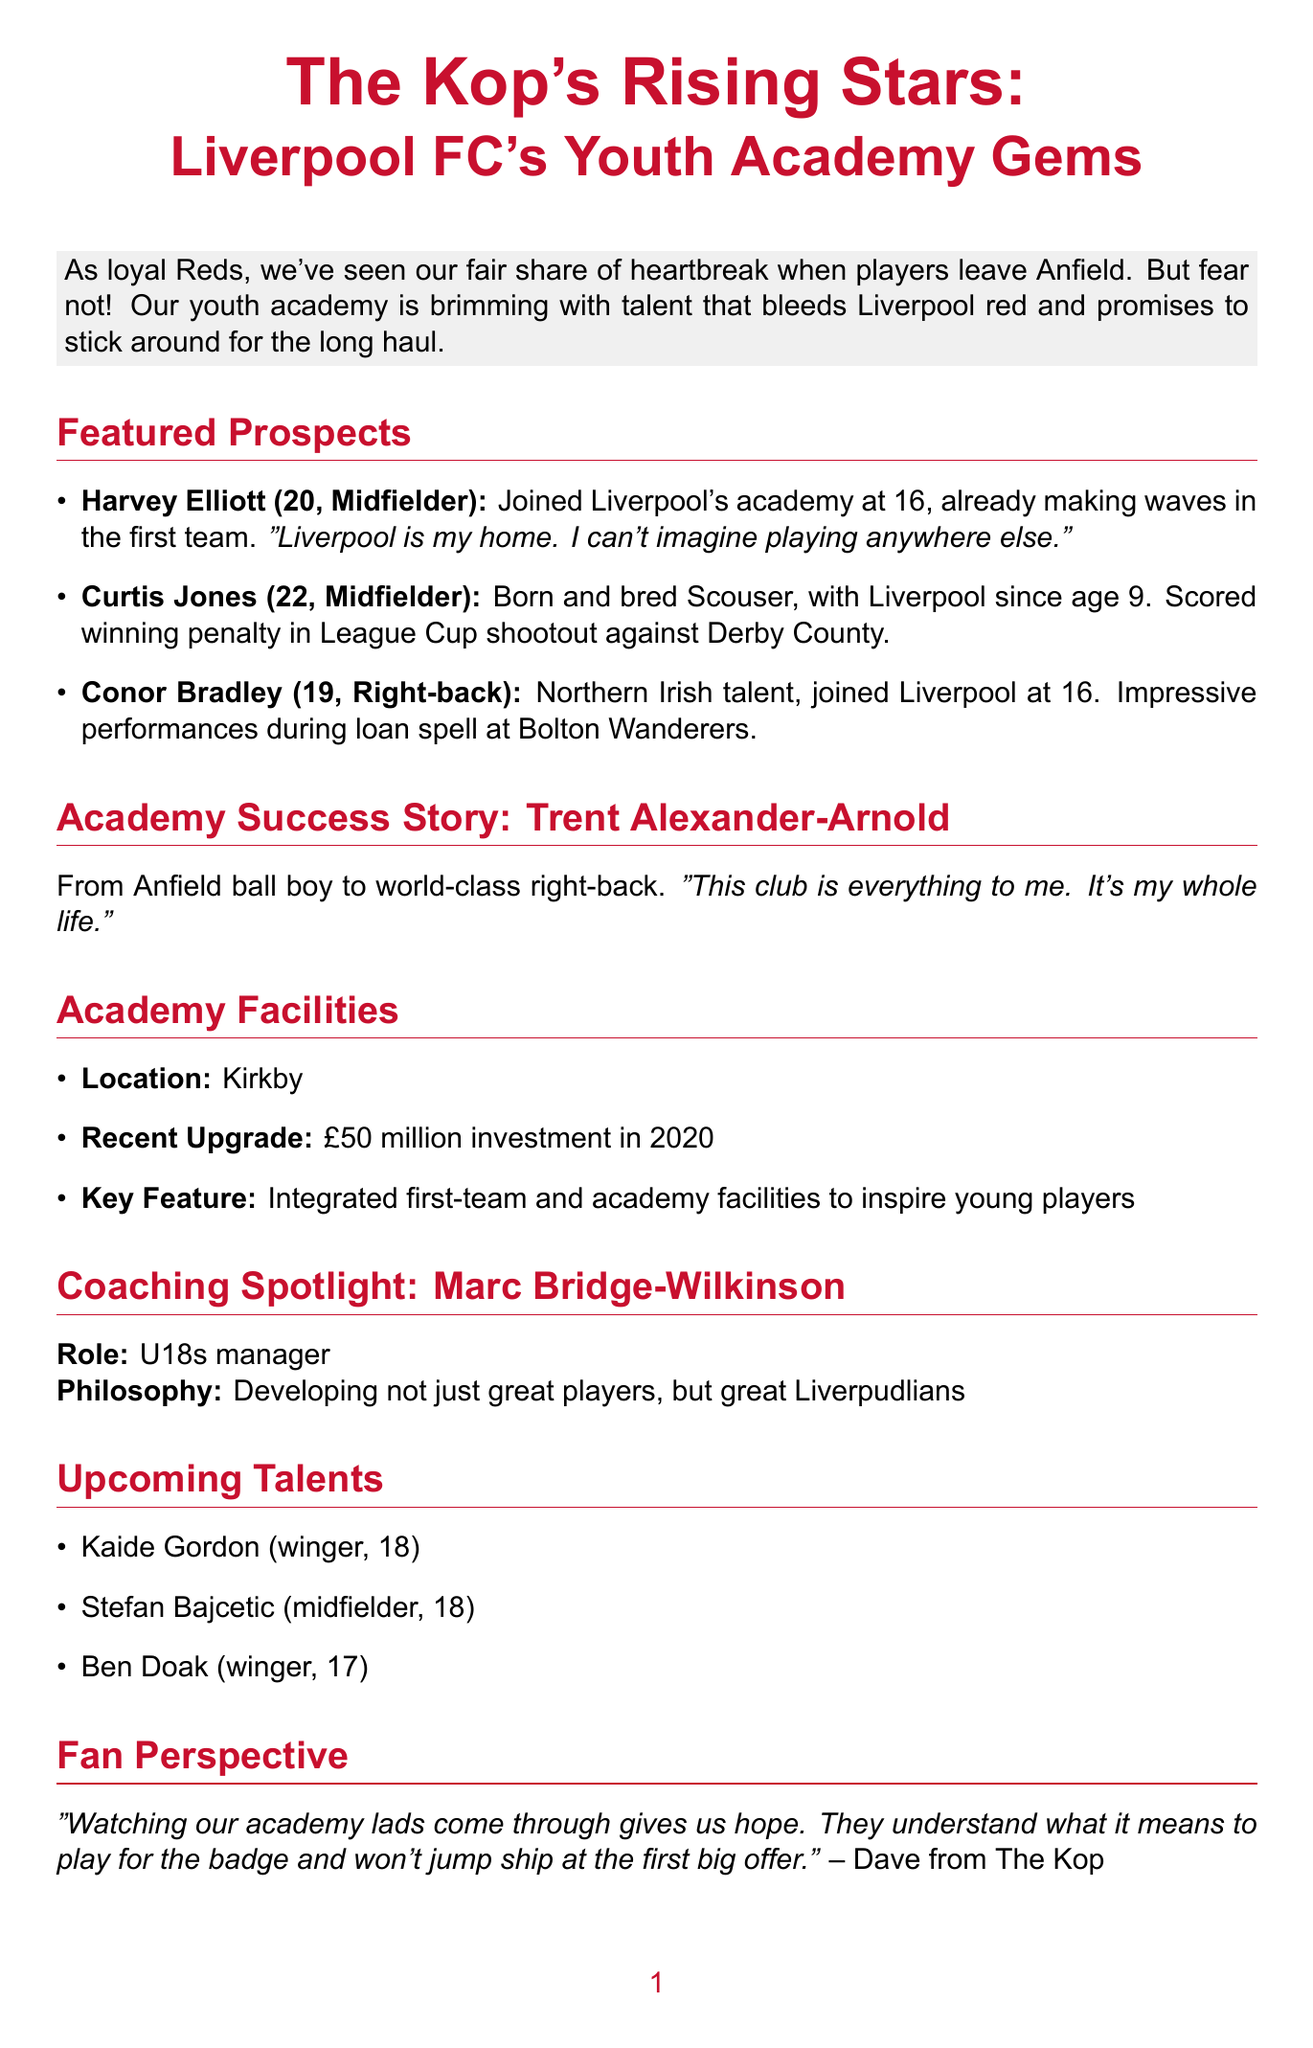What is the title of the newsletter? The title of the newsletter is stated at the beginning, introducing the topic of Liverpool FC's youth academy talents.
Answer: The Kop's Rising Stars: Liverpool FC's Youth Academy Gems Who is the U18s manager? The document mentions Marc Bridge-Wilkinson as the manager of the U18s, highlighting his role in the academy.
Answer: Marc Bridge-Wilkinson How old is Harvey Elliott? The newsletter provides the age of Harvey Elliott among the featured prospects.
Answer: 20 What significant investment was made in the academy facilities? The document indicates that a substantial investment was made to upgrade the academy facilities.
Answer: £50 million What is Curtis Jones's achievement mentioned in the newsletter? The article highlights a specific accomplishment of Curtis Jones during a match, showcasing his contributions to the team.
Answer: Scored winning penalty in League Cup shootout against Derby County Where are the academy facilities located? The document specifies the location of Liverpool's academy facilities.
Answer: Kirkby What is the philosophy of the U18s manager? The newsletter describes the core philosophy of Marc Bridge-Wilkinson regarding player development.
Answer: Developing not just great players, but great Liverpudlians Which player is noted as a success story in the academy? The document highlights a particular player who successfully transitioned from the academy to the first team.
Answer: Trent Alexander-Arnold What quote is attributed to Dave from The Kop? The newsletter includes a quote from a fan that reflects the hope and loyalty associated with academy players.
Answer: "Watching our academy lads come through gives us hope. They understand what it means to play for the badge and won't jump ship at the first big offer." 